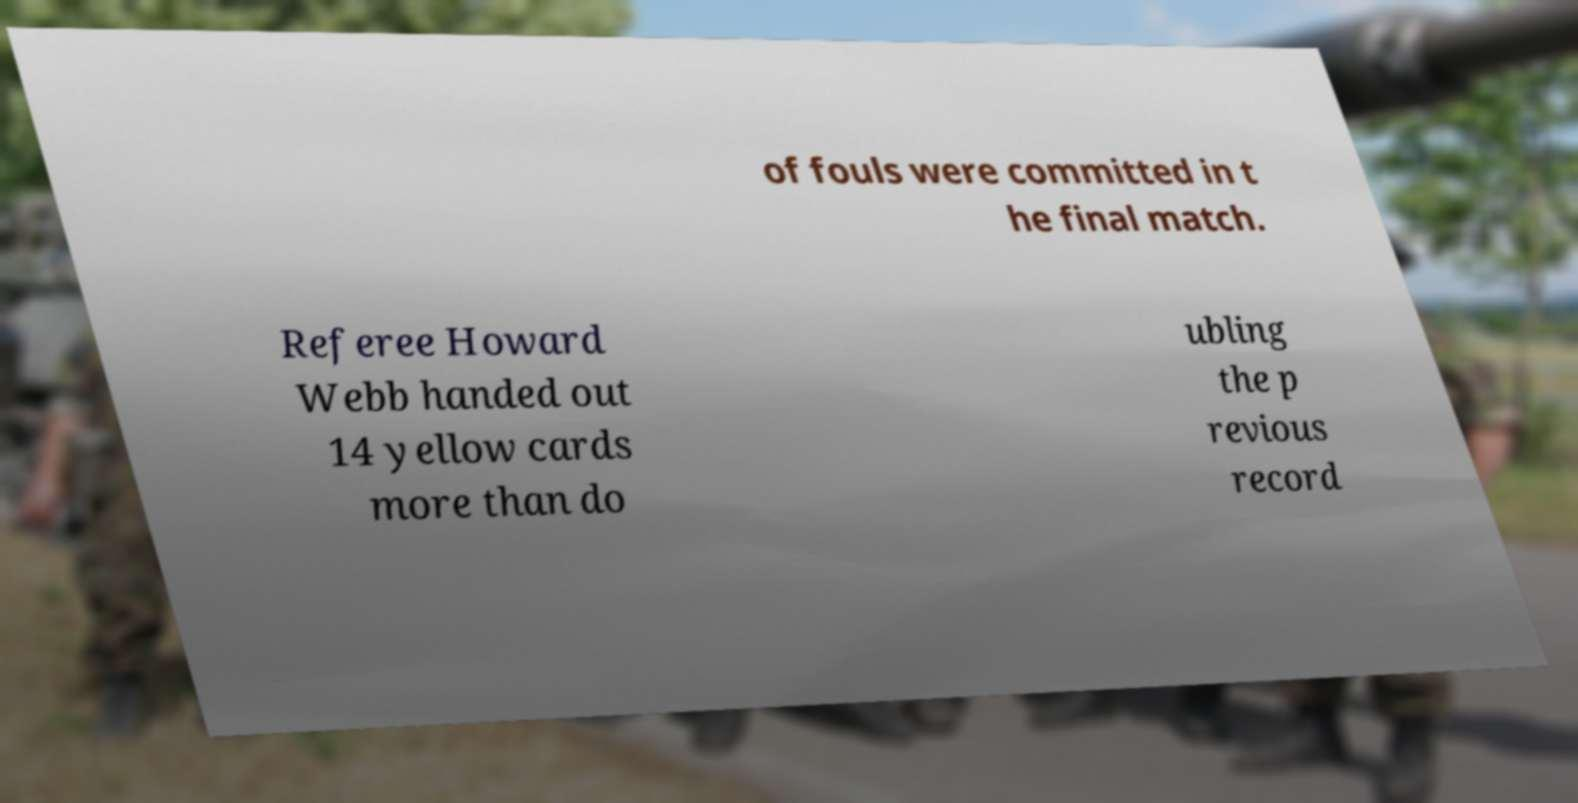Please read and relay the text visible in this image. What does it say? of fouls were committed in t he final match. Referee Howard Webb handed out 14 yellow cards more than do ubling the p revious record 